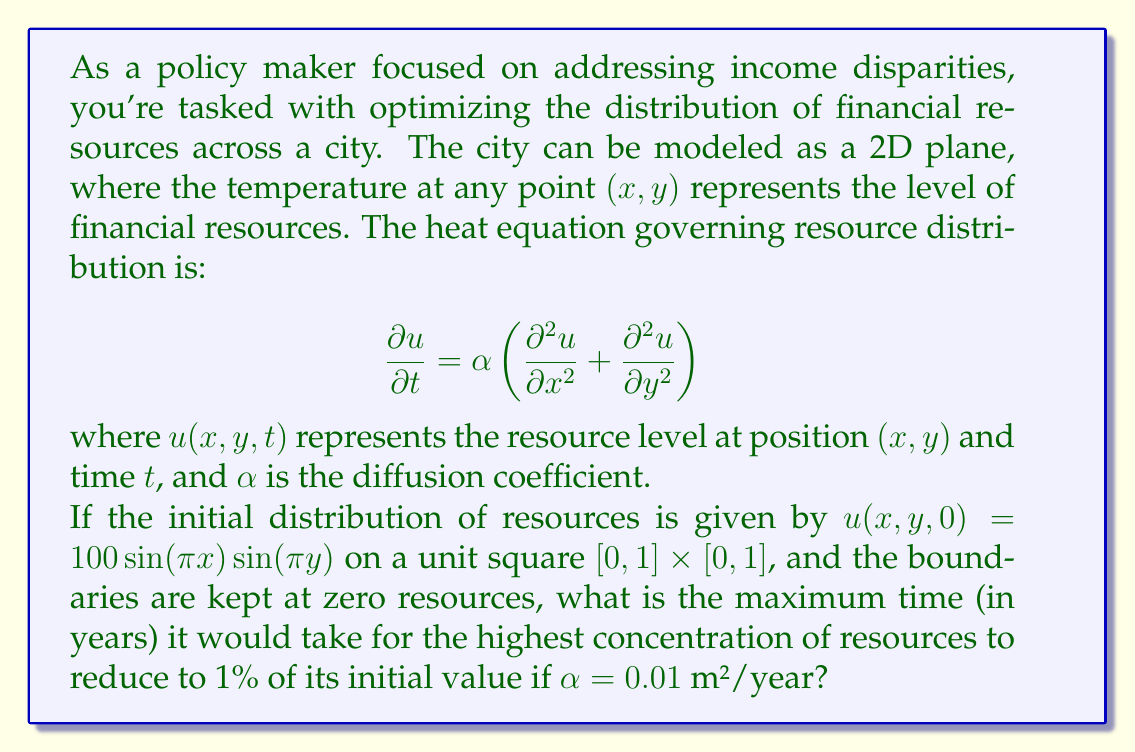Could you help me with this problem? To solve this problem, we'll follow these steps:

1) The general solution to the 2D heat equation with the given initial condition and boundary conditions is:

   $$u(x,y,t) = 100\sin(\pi x)\sin(\pi y)e^{-2\alpha\pi^2t}$$

2) The maximum value of $\sin(\pi x)\sin(\pi y)$ on the unit square is 1, occurring at $(x,y) = (0.5, 0.5)$.

3) We want to find $t$ when the maximum value reduces to 1% of its initial value:

   $$100e^{-2\alpha\pi^2t} = 1$$

4) Taking natural logarithms of both sides:

   $$\ln(0.01) = -2\alpha\pi^2t$$

5) Solving for $t$:

   $$t = -\frac{\ln(0.01)}{2\alpha\pi^2}$$

6) Substituting $\alpha = 0.01$ m²/year:

   $$t = -\frac{\ln(0.01)}{2(0.01)\pi^2} \approx 73.1$$

Therefore, it would take approximately 73.1 years for the highest concentration of resources to reduce to 1% of its initial value.
Answer: 73.1 years 